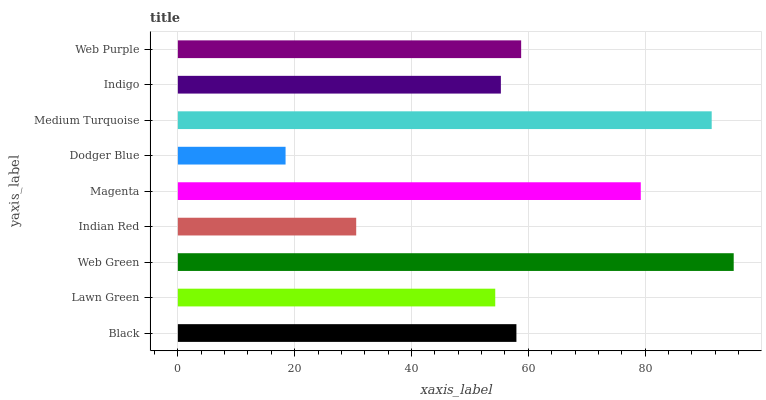Is Dodger Blue the minimum?
Answer yes or no. Yes. Is Web Green the maximum?
Answer yes or no. Yes. Is Lawn Green the minimum?
Answer yes or no. No. Is Lawn Green the maximum?
Answer yes or no. No. Is Black greater than Lawn Green?
Answer yes or no. Yes. Is Lawn Green less than Black?
Answer yes or no. Yes. Is Lawn Green greater than Black?
Answer yes or no. No. Is Black less than Lawn Green?
Answer yes or no. No. Is Black the high median?
Answer yes or no. Yes. Is Black the low median?
Answer yes or no. Yes. Is Magenta the high median?
Answer yes or no. No. Is Magenta the low median?
Answer yes or no. No. 